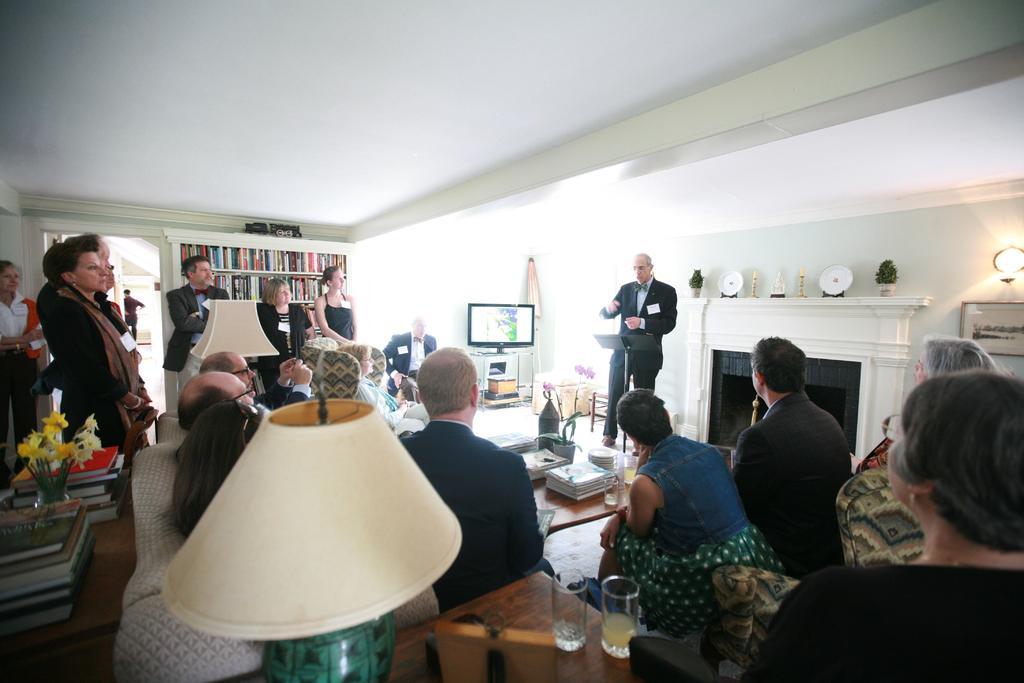Please provide a concise description of this image. In this picture i could see many persons standing and sitting around, the other person is standing and talking they all are dressed in formals i could see book shelf in the background television and fire place and in foreground there is a lamp on the corner table. 